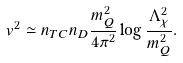Convert formula to latex. <formula><loc_0><loc_0><loc_500><loc_500>v ^ { 2 } \simeq n _ { T C } n _ { D } \frac { m _ { Q } ^ { 2 } } { 4 \pi ^ { 2 } } \log \frac { \Lambda ^ { 2 } _ { \chi } } { m _ { Q } ^ { 2 } } .</formula> 